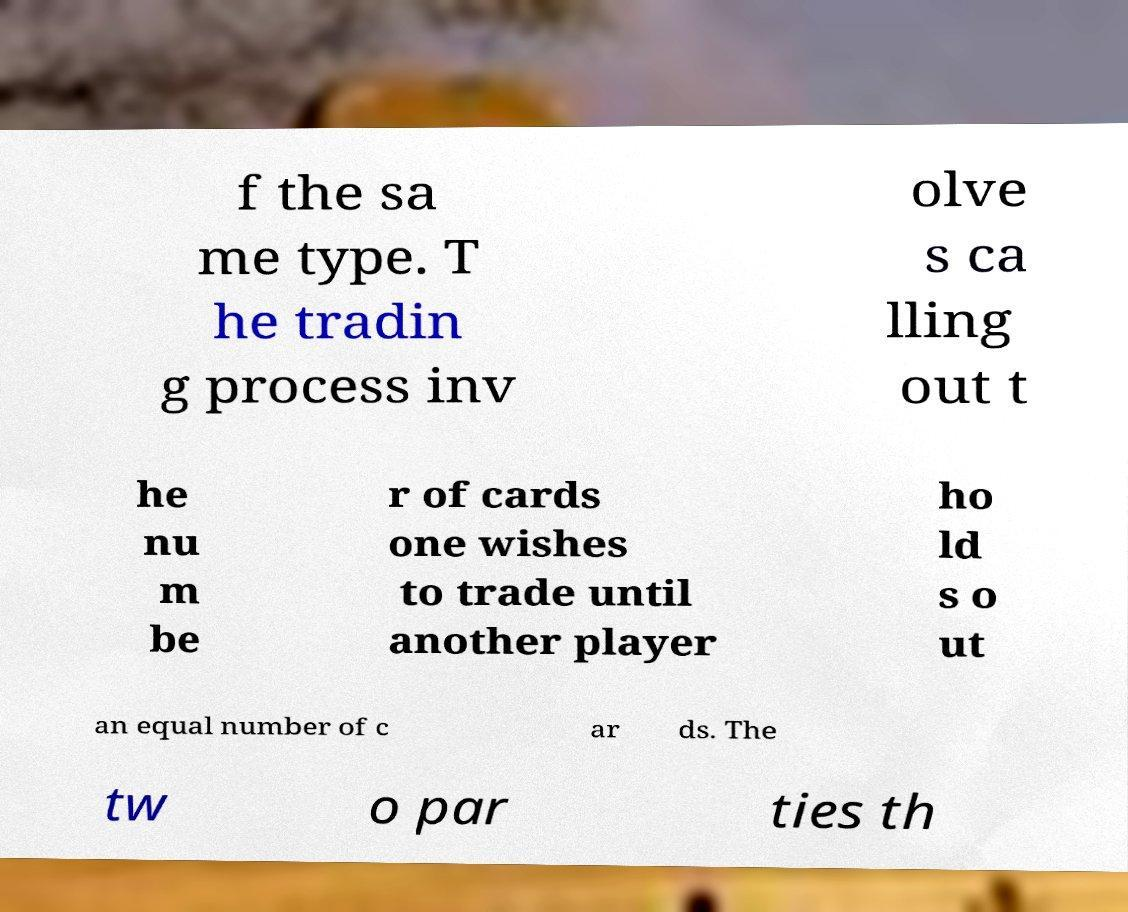Please read and relay the text visible in this image. What does it say? f the sa me type. T he tradin g process inv olve s ca lling out t he nu m be r of cards one wishes to trade until another player ho ld s o ut an equal number of c ar ds. The tw o par ties th 